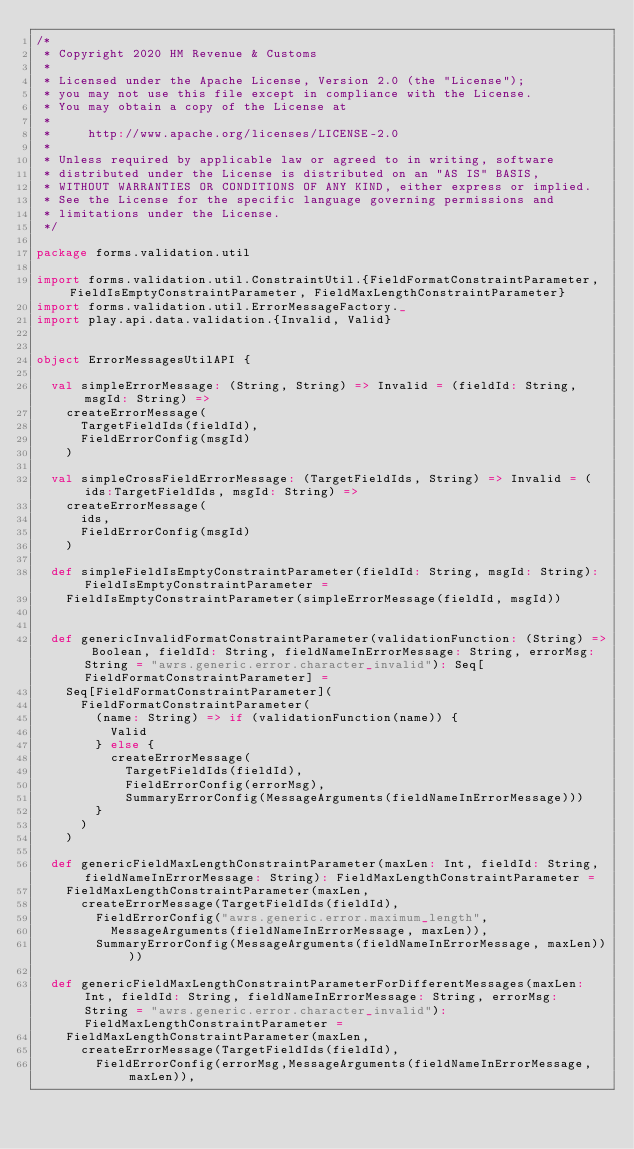<code> <loc_0><loc_0><loc_500><loc_500><_Scala_>/*
 * Copyright 2020 HM Revenue & Customs
 *
 * Licensed under the Apache License, Version 2.0 (the "License");
 * you may not use this file except in compliance with the License.
 * You may obtain a copy of the License at
 *
 *     http://www.apache.org/licenses/LICENSE-2.0
 *
 * Unless required by applicable law or agreed to in writing, software
 * distributed under the License is distributed on an "AS IS" BASIS,
 * WITHOUT WARRANTIES OR CONDITIONS OF ANY KIND, either express or implied.
 * See the License for the specific language governing permissions and
 * limitations under the License.
 */

package forms.validation.util

import forms.validation.util.ConstraintUtil.{FieldFormatConstraintParameter, FieldIsEmptyConstraintParameter, FieldMaxLengthConstraintParameter}
import forms.validation.util.ErrorMessageFactory._
import play.api.data.validation.{Invalid, Valid}


object ErrorMessagesUtilAPI {

  val simpleErrorMessage: (String, String) => Invalid = (fieldId: String, msgId: String) =>
    createErrorMessage(
      TargetFieldIds(fieldId),
      FieldErrorConfig(msgId)
    )

  val simpleCrossFieldErrorMessage: (TargetFieldIds, String) => Invalid = (ids:TargetFieldIds, msgId: String) =>
    createErrorMessage(
      ids,
      FieldErrorConfig(msgId)
    )

  def simpleFieldIsEmptyConstraintParameter(fieldId: String, msgId: String): FieldIsEmptyConstraintParameter =
    FieldIsEmptyConstraintParameter(simpleErrorMessage(fieldId, msgId))


  def genericInvalidFormatConstraintParameter(validationFunction: (String) => Boolean, fieldId: String, fieldNameInErrorMessage: String, errorMsg: String = "awrs.generic.error.character_invalid"): Seq[FieldFormatConstraintParameter] =
    Seq[FieldFormatConstraintParameter](
      FieldFormatConstraintParameter(
        (name: String) => if (validationFunction(name)) {
          Valid
        } else {
          createErrorMessage(
            TargetFieldIds(fieldId),
            FieldErrorConfig(errorMsg),
            SummaryErrorConfig(MessageArguments(fieldNameInErrorMessage)))
        }
      )
    )

  def genericFieldMaxLengthConstraintParameter(maxLen: Int, fieldId: String, fieldNameInErrorMessage: String): FieldMaxLengthConstraintParameter =
    FieldMaxLengthConstraintParameter(maxLen,
      createErrorMessage(TargetFieldIds(fieldId),
        FieldErrorConfig("awrs.generic.error.maximum_length",
          MessageArguments(fieldNameInErrorMessage, maxLen)),
        SummaryErrorConfig(MessageArguments(fieldNameInErrorMessage, maxLen))))

  def genericFieldMaxLengthConstraintParameterForDifferentMessages(maxLen: Int, fieldId: String, fieldNameInErrorMessage: String, errorMsg: String = "awrs.generic.error.character_invalid"): FieldMaxLengthConstraintParameter =
    FieldMaxLengthConstraintParameter(maxLen,
      createErrorMessage(TargetFieldIds(fieldId),
        FieldErrorConfig(errorMsg,MessageArguments(fieldNameInErrorMessage, maxLen)),</code> 